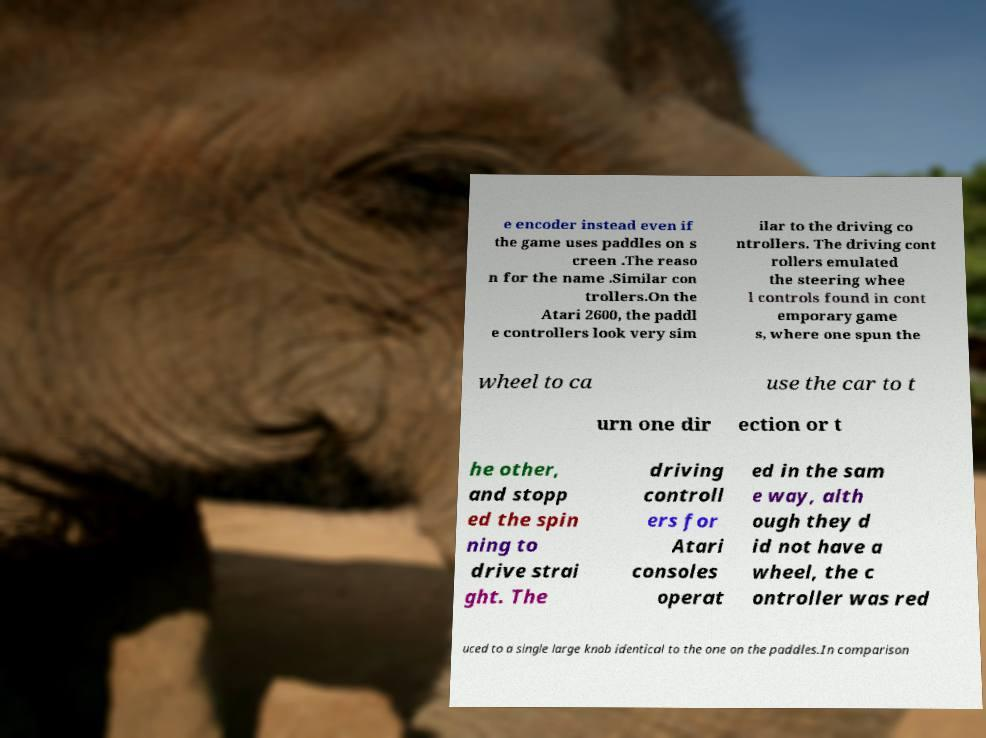Could you extract and type out the text from this image? e encoder instead even if the game uses paddles on s creen .The reaso n for the name .Similar con trollers.On the Atari 2600, the paddl e controllers look very sim ilar to the driving co ntrollers. The driving cont rollers emulated the steering whee l controls found in cont emporary game s, where one spun the wheel to ca use the car to t urn one dir ection or t he other, and stopp ed the spin ning to drive strai ght. The driving controll ers for Atari consoles operat ed in the sam e way, alth ough they d id not have a wheel, the c ontroller was red uced to a single large knob identical to the one on the paddles.In comparison 